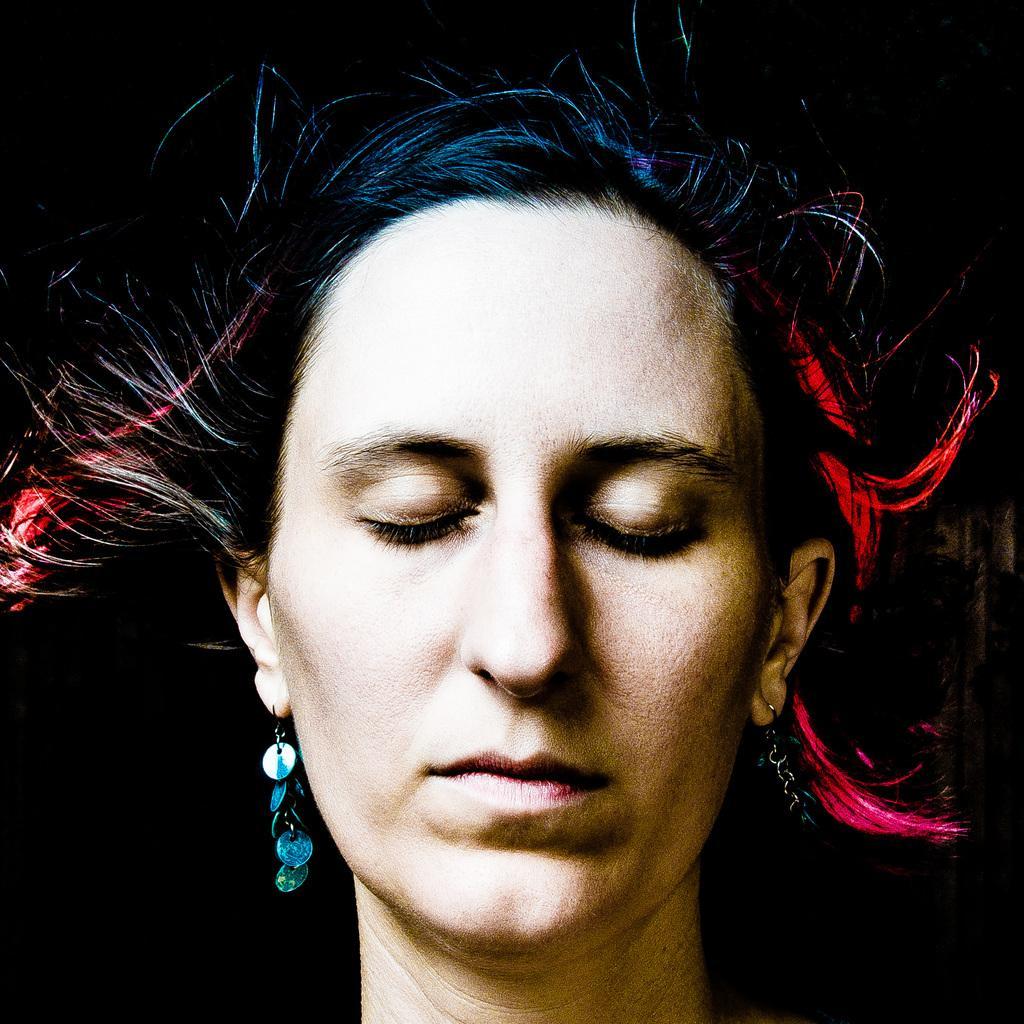Can you describe this image briefly? In this picture we can see a woman and in the background we can see it is dark. 